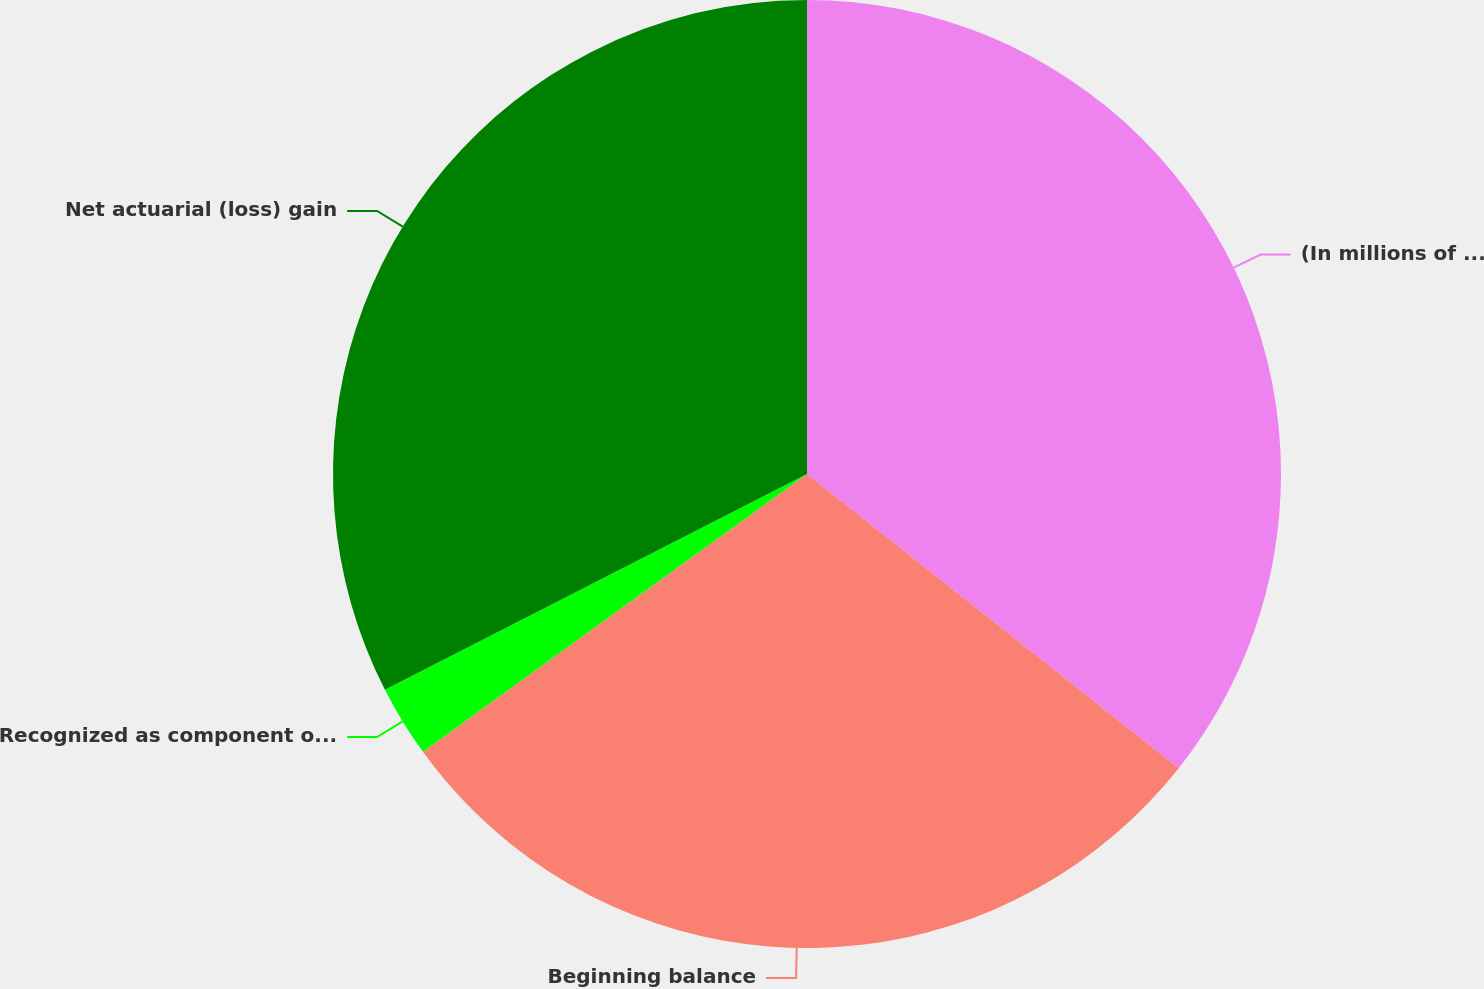Convert chart. <chart><loc_0><loc_0><loc_500><loc_500><pie_chart><fcel>(In millions of dollars)<fcel>Beginning balance<fcel>Recognized as component of net<fcel>Net actuarial (loss) gain<nl><fcel>35.66%<fcel>29.38%<fcel>2.45%<fcel>32.52%<nl></chart> 